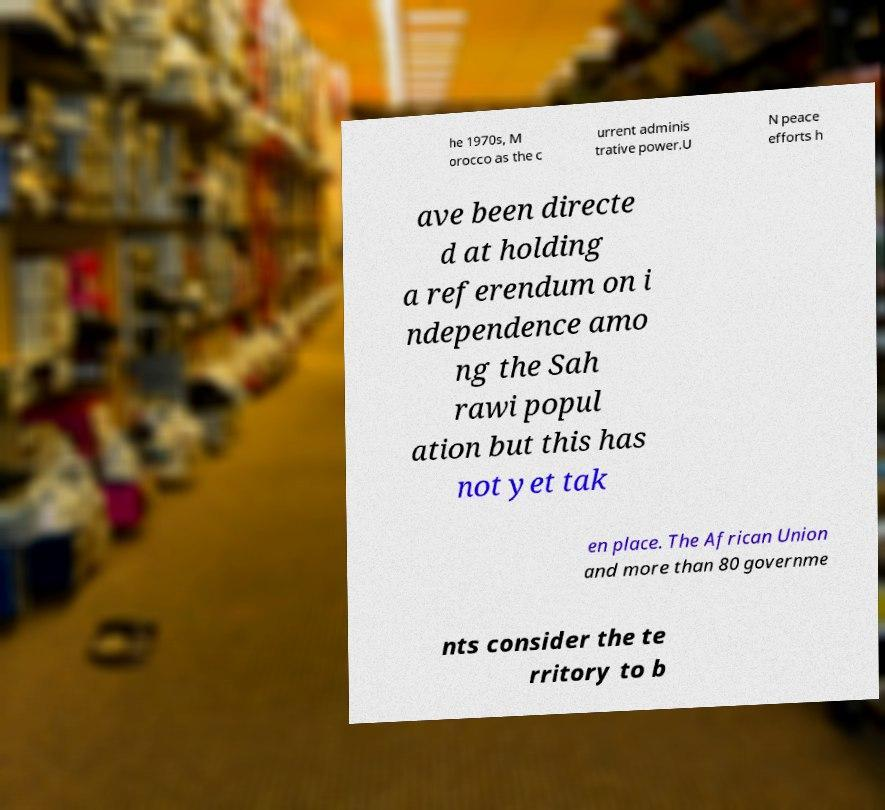I need the written content from this picture converted into text. Can you do that? he 1970s, M orocco as the c urrent adminis trative power.U N peace efforts h ave been directe d at holding a referendum on i ndependence amo ng the Sah rawi popul ation but this has not yet tak en place. The African Union and more than 80 governme nts consider the te rritory to b 